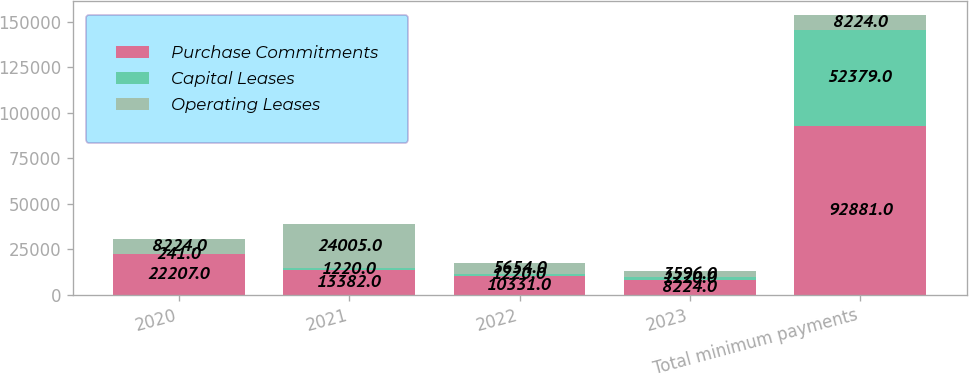Convert chart. <chart><loc_0><loc_0><loc_500><loc_500><stacked_bar_chart><ecel><fcel>2020<fcel>2021<fcel>2022<fcel>2023<fcel>Total minimum payments<nl><fcel>Purchase Commitments<fcel>22207<fcel>13382<fcel>10331<fcel>8224<fcel>92881<nl><fcel>Capital Leases<fcel>241<fcel>1220<fcel>1220<fcel>1220<fcel>52379<nl><fcel>Operating Leases<fcel>8224<fcel>24005<fcel>5654<fcel>3596<fcel>8224<nl></chart> 